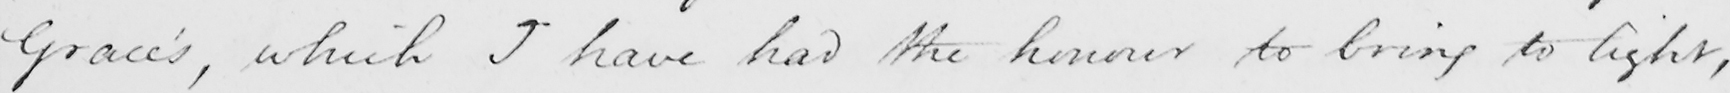Can you read and transcribe this handwriting? Grace ' s , which I have had the honour to bring to light , 